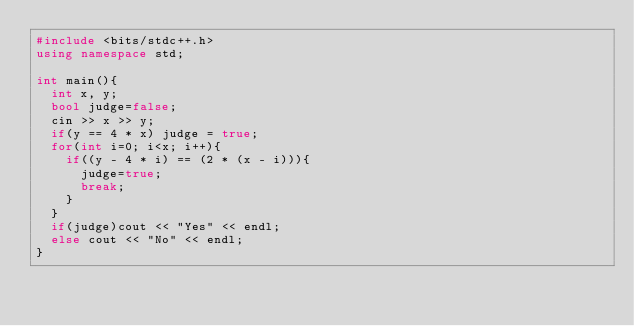<code> <loc_0><loc_0><loc_500><loc_500><_C++_>#include <bits/stdc++.h>
using namespace std;

int main(){
  int x, y;
  bool judge=false;
  cin >> x >> y;
  if(y == 4 * x) judge = true;
  for(int i=0; i<x; i++){
    if((y - 4 * i) == (2 * (x - i))){
      judge=true;
      break;
    }
  }
  if(judge)cout << "Yes" << endl;
  else cout << "No" << endl;
}</code> 